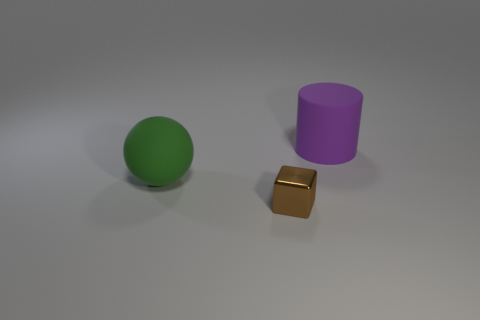Add 3 yellow cubes. How many objects exist? 6 Subtract all spheres. How many objects are left? 2 Add 3 small purple matte blocks. How many small purple matte blocks exist? 3 Subtract 0 green cylinders. How many objects are left? 3 Subtract 1 cylinders. How many cylinders are left? 0 Subtract all cyan blocks. Subtract all gray cylinders. How many blocks are left? 1 Subtract all purple cubes. How many gray cylinders are left? 0 Subtract all large rubber cylinders. Subtract all purple cylinders. How many objects are left? 1 Add 1 rubber spheres. How many rubber spheres are left? 2 